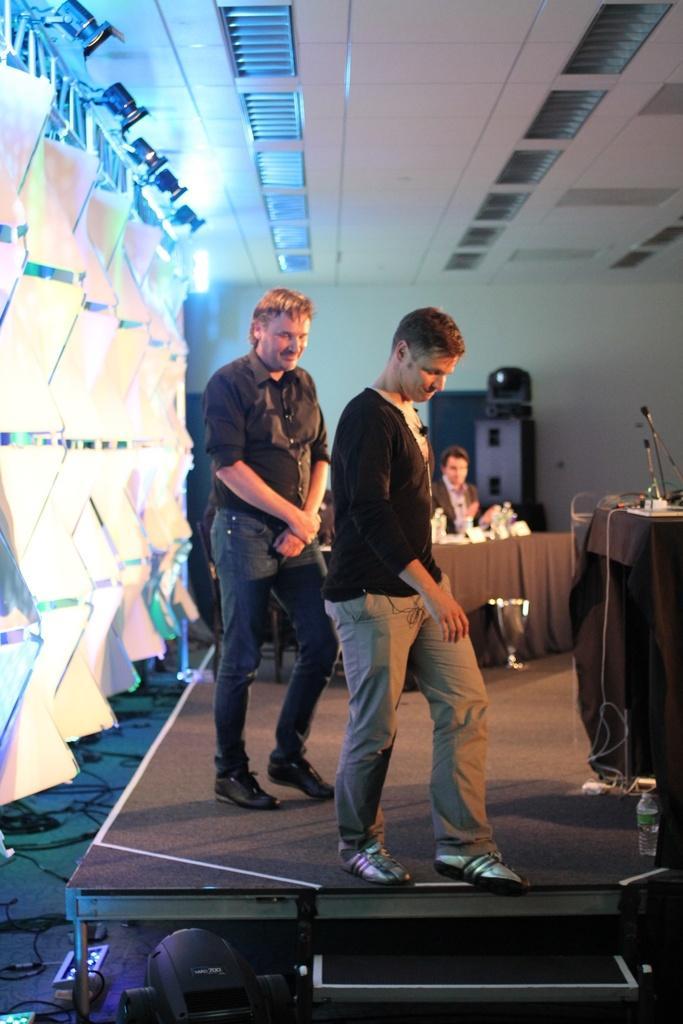Could you give a brief overview of what you see in this image? In this image I can see two men are standing and I can see both of them are wearing black dress and shoes. I can also see few mics here and in the background I can see one more person. On left side of this image I can see number of white colour things and few lights. I can also see a water bottle over here. 